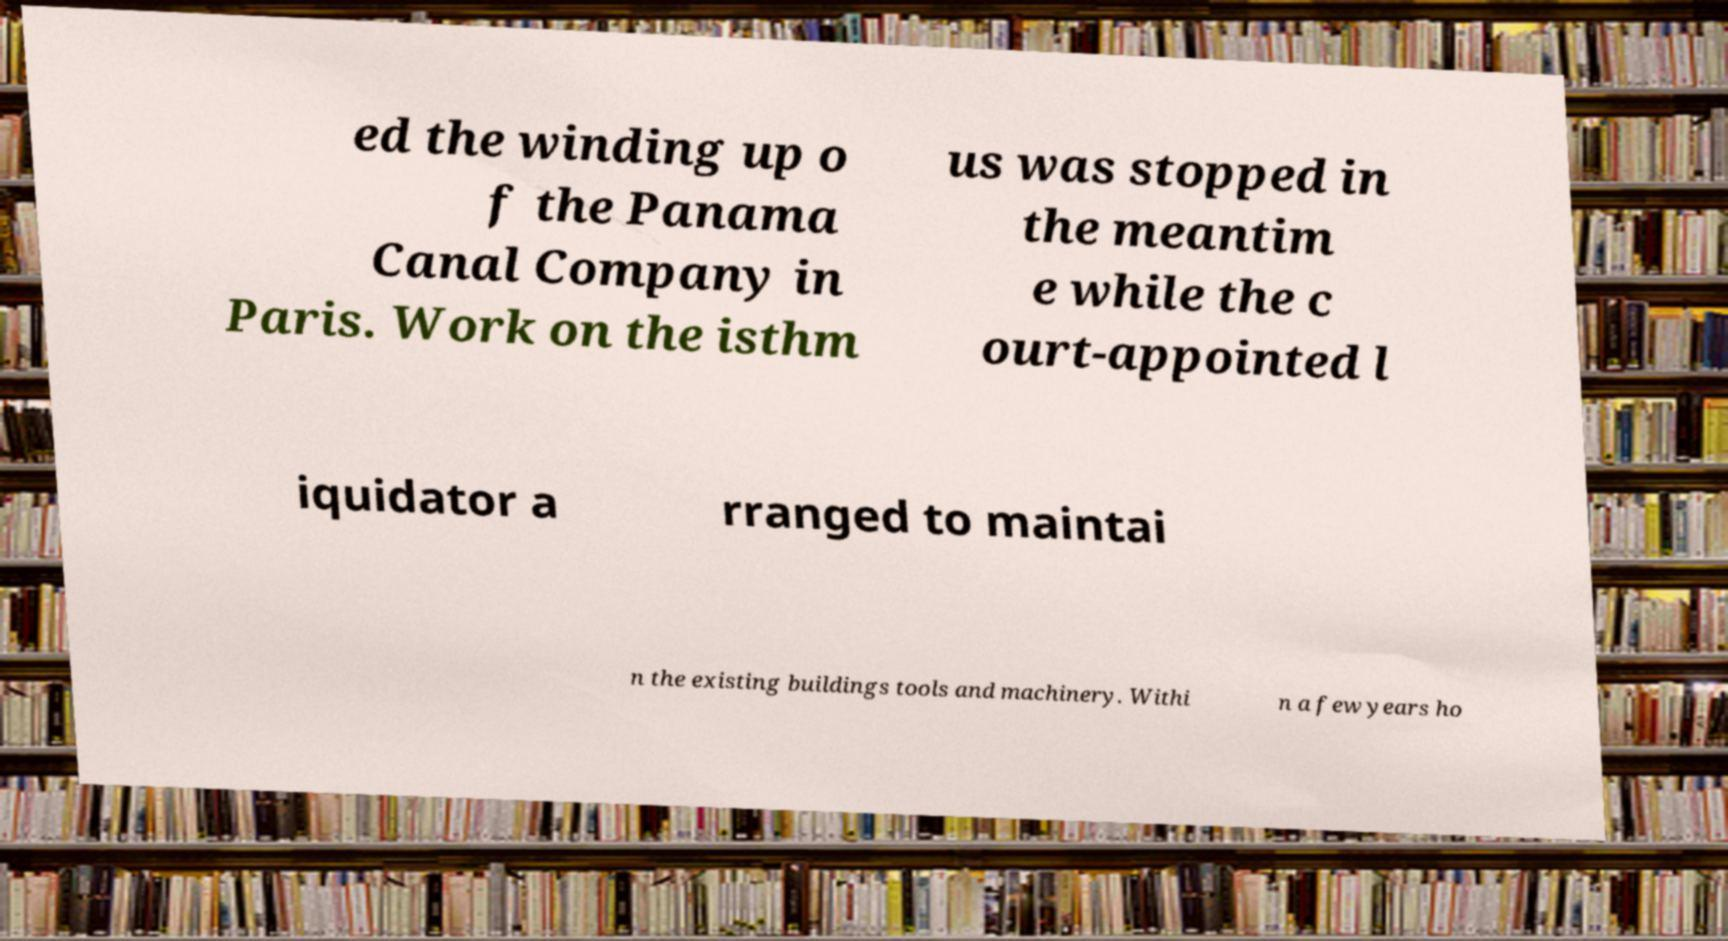Could you extract and type out the text from this image? ed the winding up o f the Panama Canal Company in Paris. Work on the isthm us was stopped in the meantim e while the c ourt-appointed l iquidator a rranged to maintai n the existing buildings tools and machinery. Withi n a few years ho 